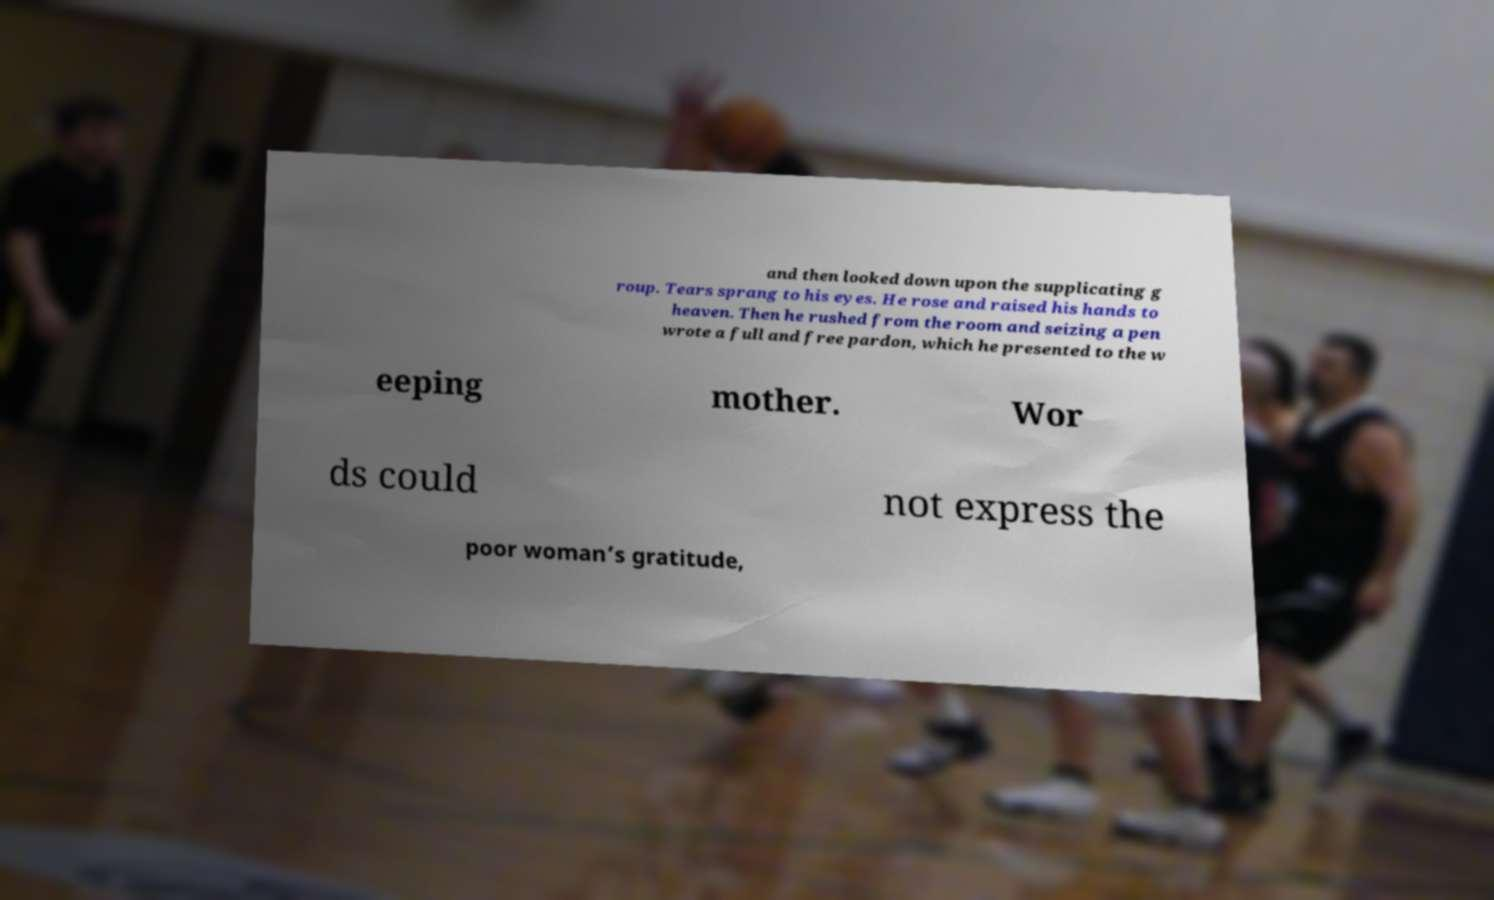What messages or text are displayed in this image? I need them in a readable, typed format. and then looked down upon the supplicating g roup. Tears sprang to his eyes. He rose and raised his hands to heaven. Then he rushed from the room and seizing a pen wrote a full and free pardon, which he presented to the w eeping mother. Wor ds could not express the poor woman’s gratitude, 